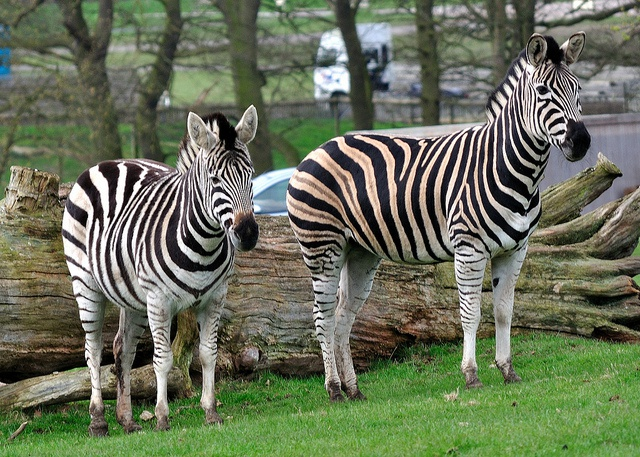Describe the objects in this image and their specific colors. I can see zebra in darkgreen, black, darkgray, lightgray, and gray tones, zebra in darkgreen, black, white, darkgray, and gray tones, and truck in darkgreen, gray, darkgray, and lavender tones in this image. 